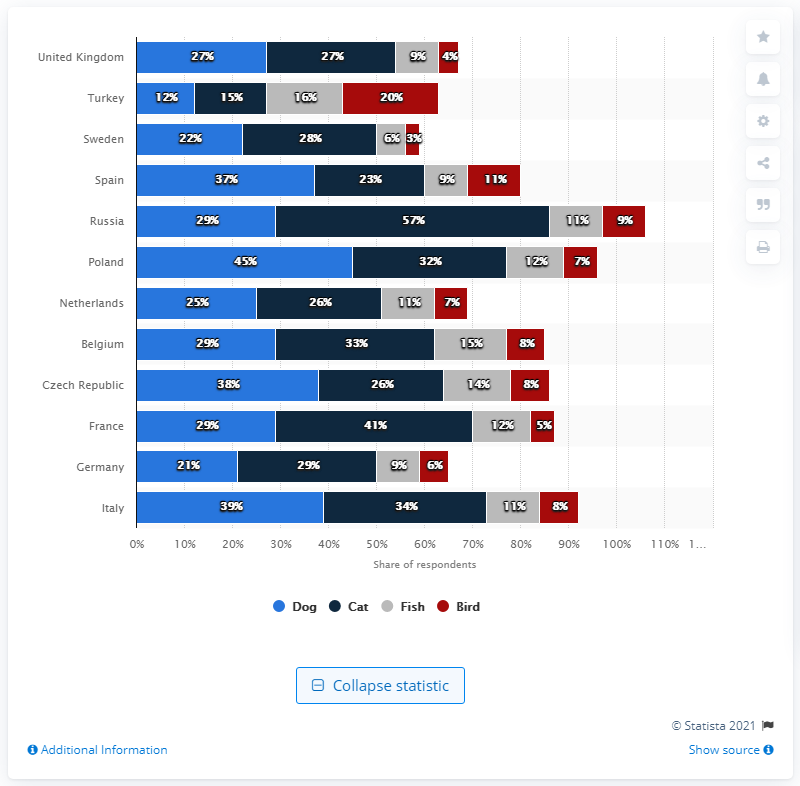Which country has the greatest pet ownership? Based on the bar graph, Italy has the greatest pet ownership percentage, with 39% of respondents owning dogs and 34% owning cats, which are the highest figures shown for those pet categories among the listed countries. 